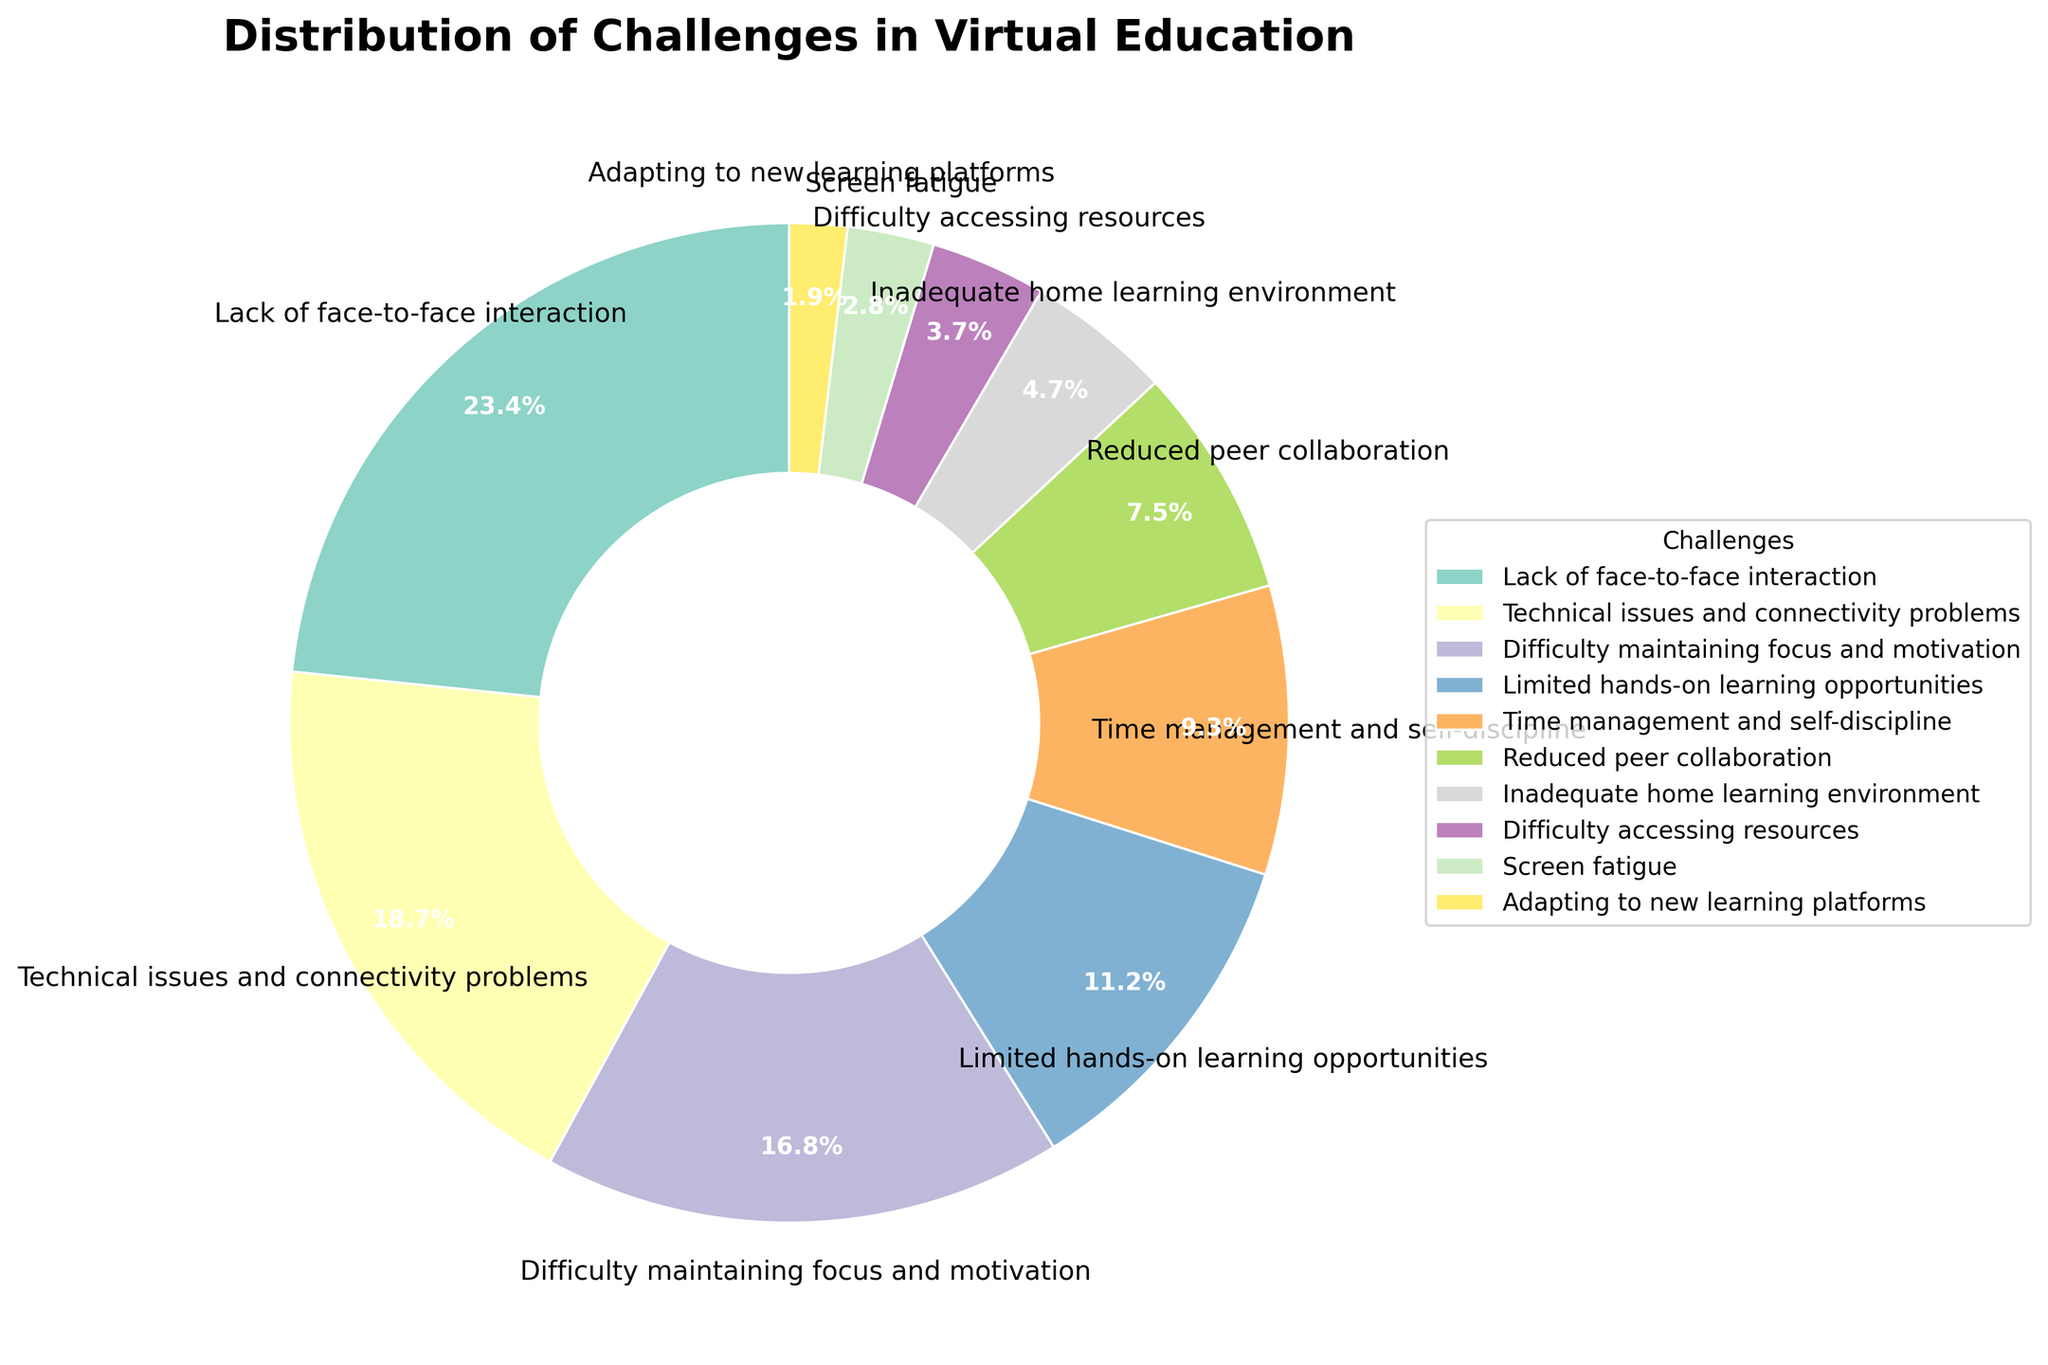What percentage of students face difficulty with technical issues and connectivity problems? Look at the segment labeled "Technical issues and connectivity problems." The label indicates it accounts for 20%.
Answer: 20% How does the percentage of students facing 'Difficulty maintaining focus and motivation' compare to those experiencing 'Limited hands-on learning opportunities'? The percentage for 'Difficulty maintaining focus and motivation' is 18%, while for 'Limited hands-on learning opportunities' it is 12%. Compare 18% and 12%.
Answer: Difficulty maintaining focus and motivation is higher by 6% What is the total percentage of students facing either 'Lack of face-to-face interaction' or 'Screen fatigue'? Add the percentage values for 'Lack of face-to-face interaction' (25%) and 'Screen fatigue' (3%).
Answer: 28% Which challenge has a higher percentage, 'Time management and self-discipline' or 'Reduced peer collaboration'? Compare the percentage for 'Time management and self-discipline' (10%) with 'Reduced peer collaboration' (8%).
Answer: Time management and self-discipline is higher Based on the chart, what is the percentage difference between the most and least reported challenges? The most reported challenge is 'Lack of face-to-face interaction' at 25% and the least is 'Adapting to new learning platforms' at 2%. Subtract 2% from 25%.
Answer: 23% Which three challenges combined account for the majority of the distribution? Identify the top three highest percentage challenges: 'Lack of face-to-face interaction' (25%), 'Technical issues and connectivity problems' (20%), and 'Difficulty maintaining focus and motivation' (18%). Add them: 25% + 20% + 18% = 63%, which is more than 50%.
Answer: Lack of face-to-face interaction, Technical issues and connectivity problems, Difficulty maintaining focus and motivation How much greater is the percentage of students facing 'Inadequate home learning environment' compared to 'Difficulty accessing resources'? Compare the percentage of 'Inadequate home learning environment' (5%) with 'Difficulty accessing resources' (4%). The difference is 5% - 4%.
Answer: 1% If you combine the challenges related to 'Technical issues and connectivity problems', 'Difficulty maintaining focus and motivation', and 'Screen fatigue', what percentage of the total do they represent? Add the percentages for 'Technical issues and connectivity problems' (20%), 'Difficulty maintaining focus and motivation' (18%), and 'Screen fatigue' (3%). Total is 20% + 18% + 3% = 41%.
Answer: 41% How does the percentage of students facing 'Adapting to new learning platforms' compare to those facing 'Inadequate home learning environment'? Compare the percentage for 'Adapting to new learning platforms' (2%) with 'Inadequate home learning environment' (5%).
Answer: Adapting to new learning platforms is lower 